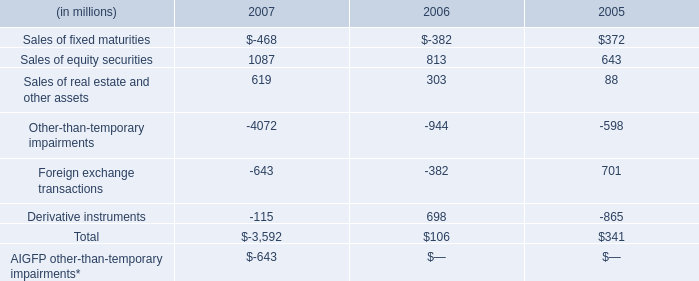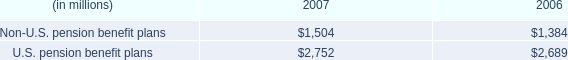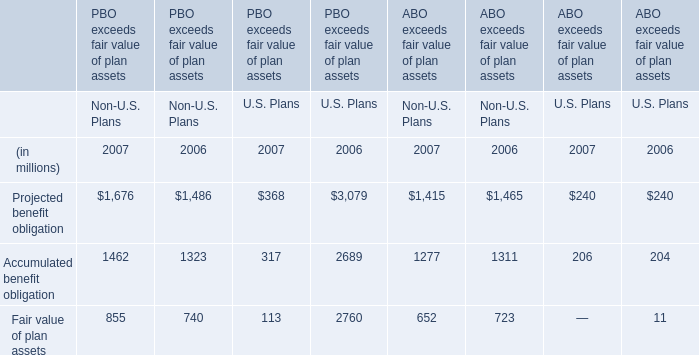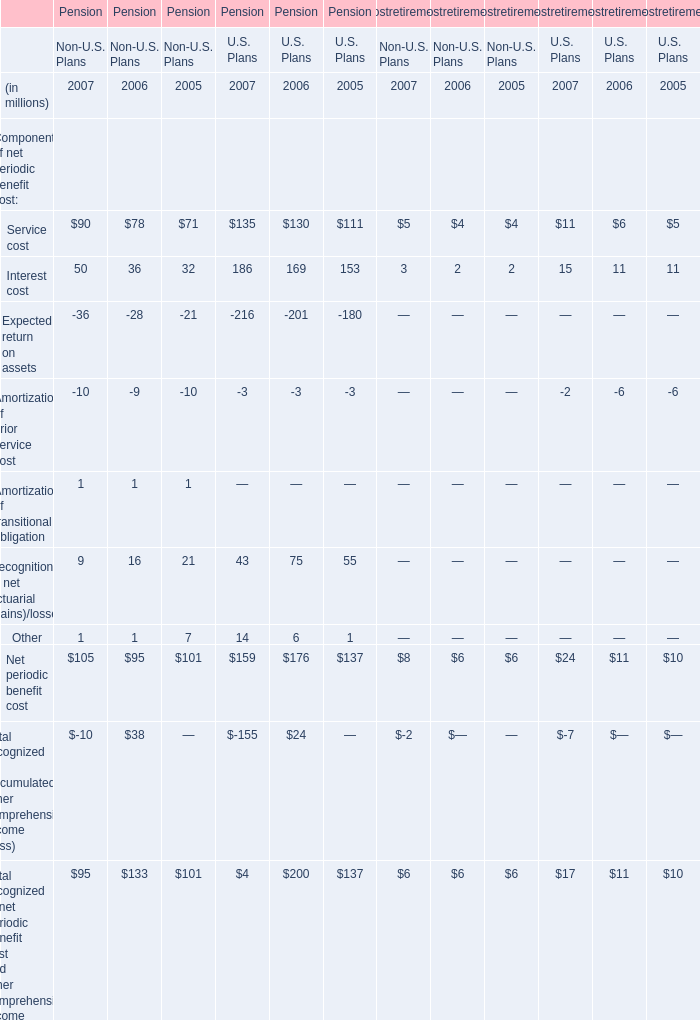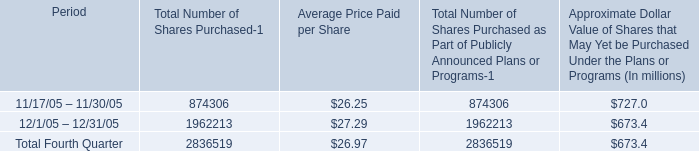What's the sum of service cost in 2007? (in million) 
Computations: (((90 + 135) + 5) + 11)
Answer: 241.0. 